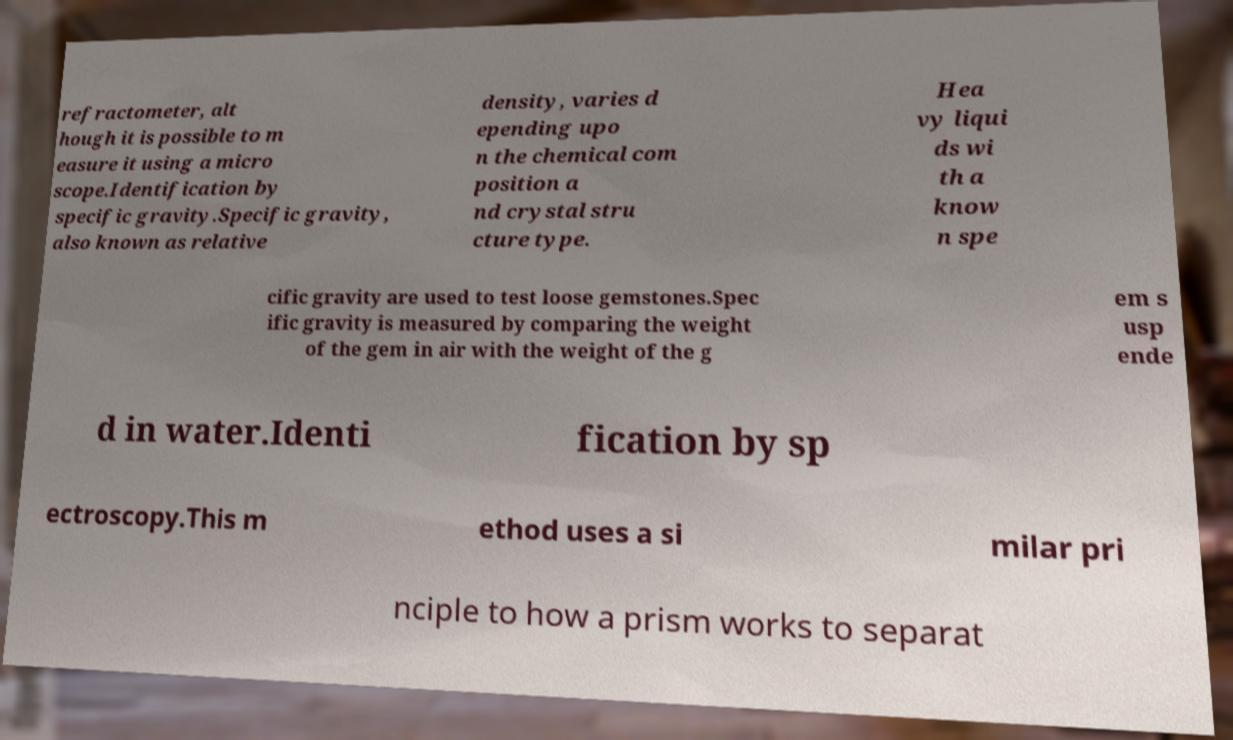Can you read and provide the text displayed in the image?This photo seems to have some interesting text. Can you extract and type it out for me? refractometer, alt hough it is possible to m easure it using a micro scope.Identification by specific gravity.Specific gravity, also known as relative density, varies d epending upo n the chemical com position a nd crystal stru cture type. Hea vy liqui ds wi th a know n spe cific gravity are used to test loose gemstones.Spec ific gravity is measured by comparing the weight of the gem in air with the weight of the g em s usp ende d in water.Identi fication by sp ectroscopy.This m ethod uses a si milar pri nciple to how a prism works to separat 